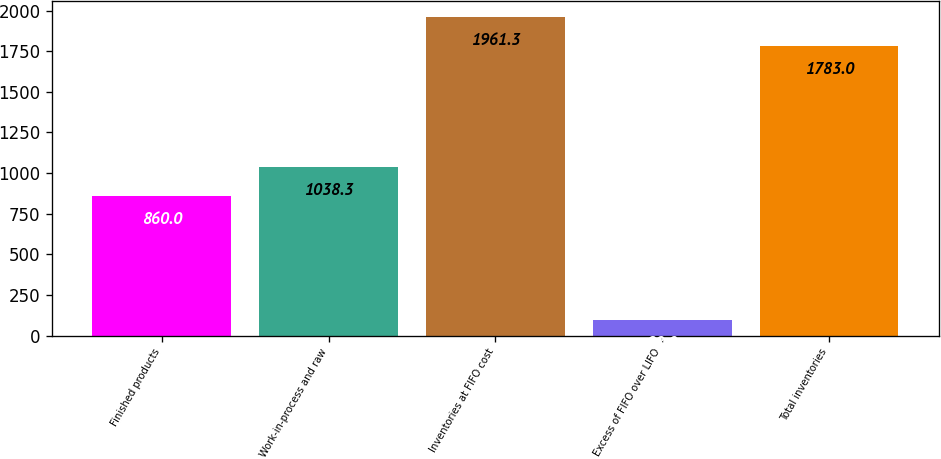Convert chart to OTSL. <chart><loc_0><loc_0><loc_500><loc_500><bar_chart><fcel>Finished products<fcel>Work-in-process and raw<fcel>Inventories at FIFO cost<fcel>Excess of FIFO over LIFO<fcel>Total inventories<nl><fcel>860<fcel>1038.3<fcel>1961.3<fcel>98<fcel>1783<nl></chart> 